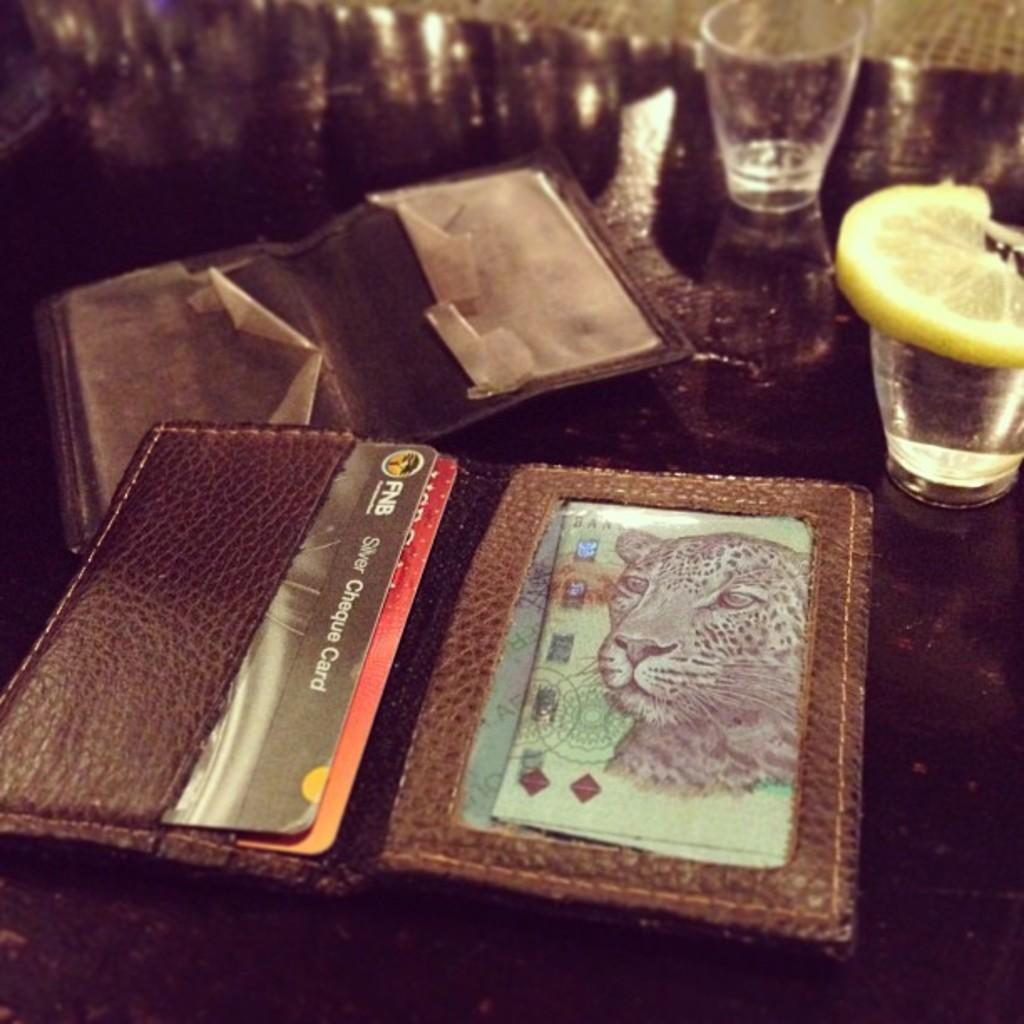Provide a one-sentence caption for the provided image. A wallet filled with cards including a silver cheque card. 